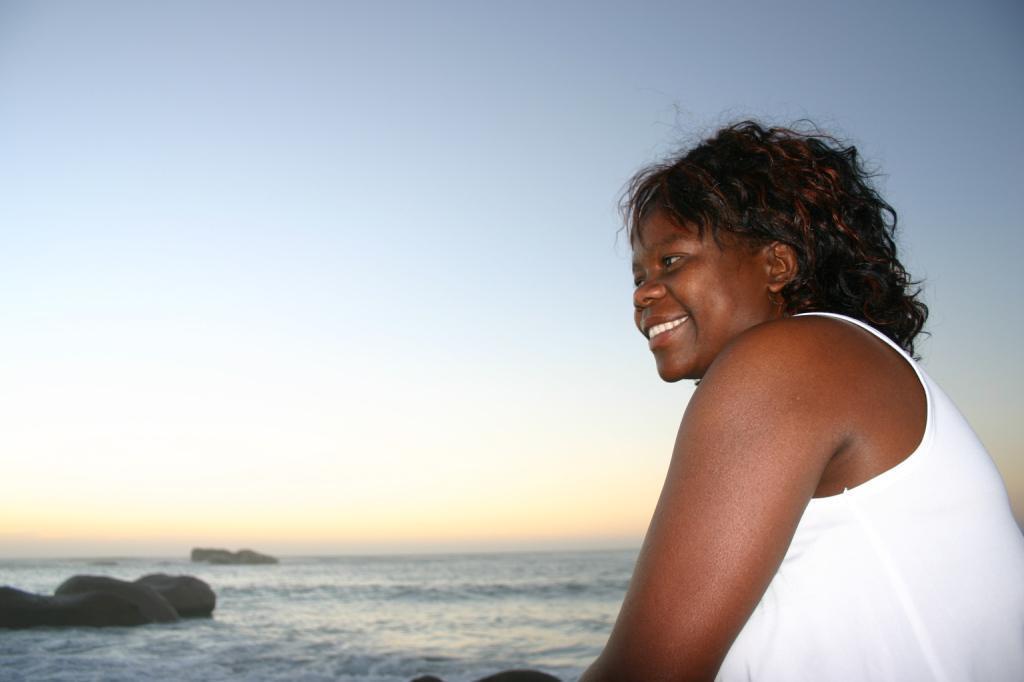Please provide a concise description of this image. As we can see in the image there is a woman standing on the right side and there is water. On the top there is sky. 